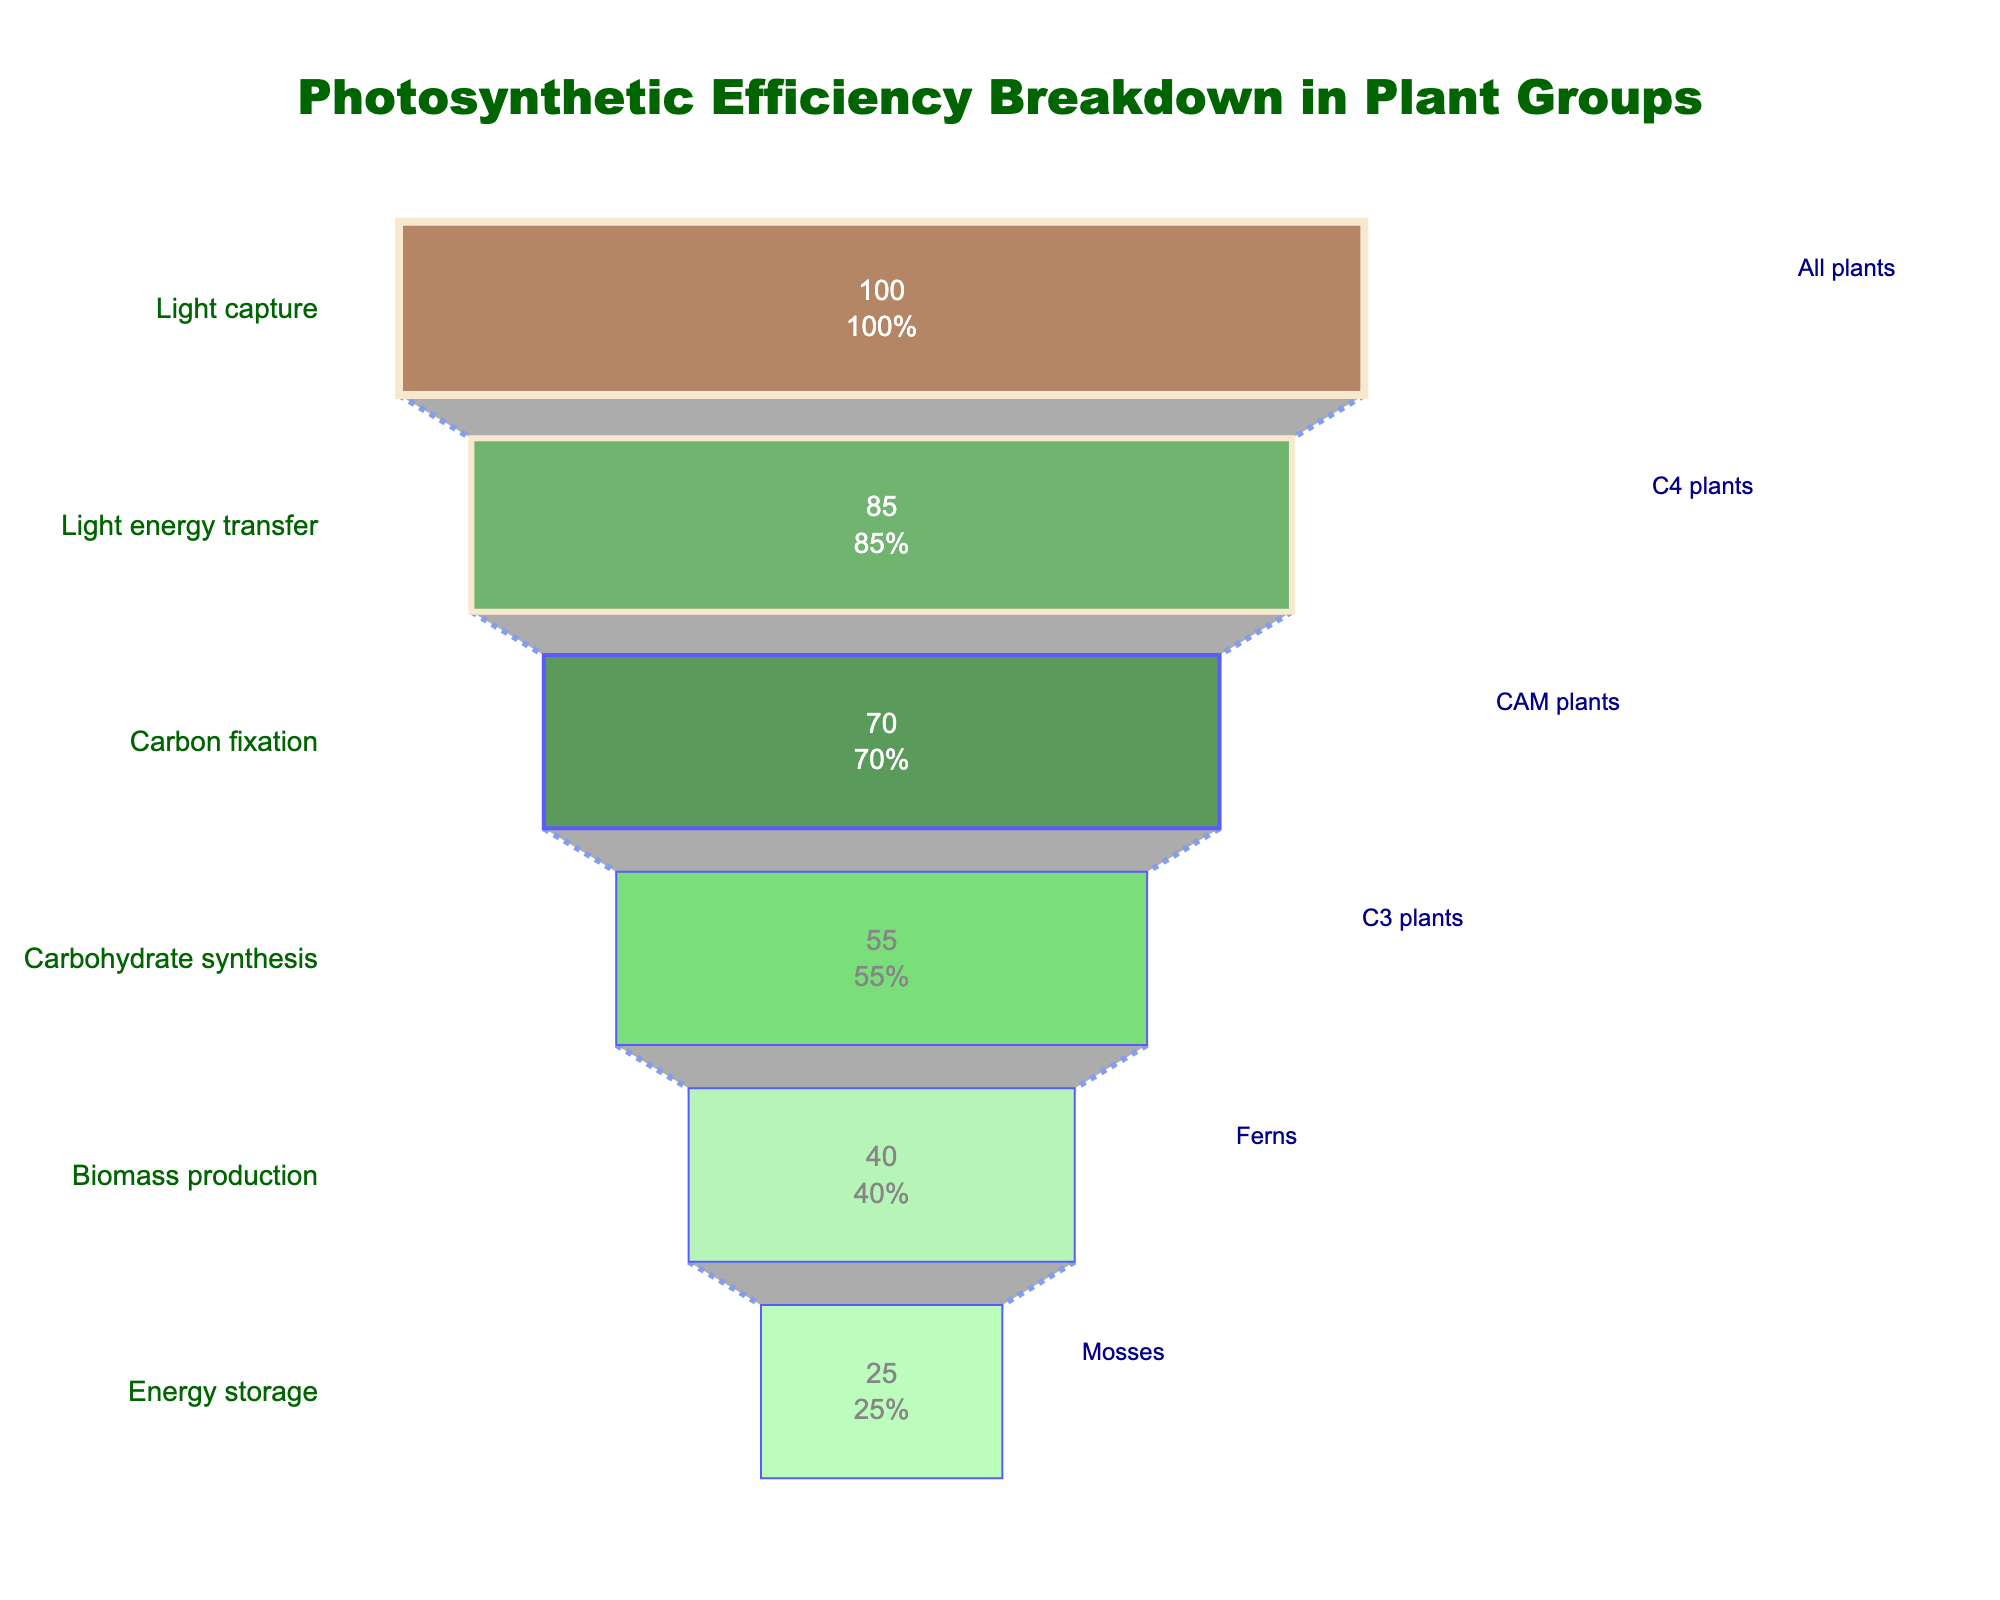What's the stage with the highest photosynthetic efficiency? Look at the funnel chart and identify the stage with the highest value on the x-axis corresponding to the Photosynthetic Efficiency (%).
Answer: Light capture Which plant group has the lowest photosynthetic efficiency? Examine the funnel chart and find the plant group with the smallest photosynthetic efficiency value on the x-axis.
Answer: Mosses What is the photosynthetic efficiency of CAM plants? Locate the "Carbon fixation" stage on the y-axis and find the associated Photosynthetic Efficiency (%) value on the x-axis.
Answer: 70% Which two plant groups are compared in terms of energy storage and biomass production stages? Identify the plant groups listed near the "Energy storage" and "Biomass production" stages on the y-axis.
Answer: Mosses and Ferns What’s the difference in photosynthetic efficiency between C4 plants and C3 plants? Find the Photosynthetic Efficiency (%) values for both stages and subtract the efficiency of the C3 plants from the efficiency of the C4 plants; 85% - 55% = 30.
Answer: 30% What's the median value of the photosynthetic efficiency across all plant groups? Arrange the efficiency values in numerical order: 25, 40, 55, 70, 85, 100. The median of six values is the average of the third and fourth values: (55 + 70) / 2 = 62.5.
Answer: 62.5% Which stage has a greater photosynthetic efficiency: Light energy transfer or Carbohydrate synthesis? Compare the Photosynthetic Efficiency (%) values for "Light energy transfer" (85%) and "Carbohydrate synthesis" (55%). The higher value indicates the greater efficiency.
Answer: Light energy transfer Are the photosynthetic efficiency values for Ferns less than half of those of C4 plants? Check the Photosynthetic Efficiency (%) values for Ferns (40%) and C4 plants (85%) and see if 40 is less than half of 85 (42.5).
Answer: Yes How much does photosynthetic efficiency decrease from the Light capture stage to the Biomass production stage? Subtract the efficiency at the "Biomass production" stage from that at the "Light capture" stage: 100% - 40% = 60%.
Answer: 60% What's the sum of the photosynthetic efficiency values of the energy storage and light energy transfer stages? Add the Photosynthetic Efficiency (%) values for "Energy storage" (25%) and "Light energy transfer" (85%): 25% + 85% = 110%.
Answer: 110% 